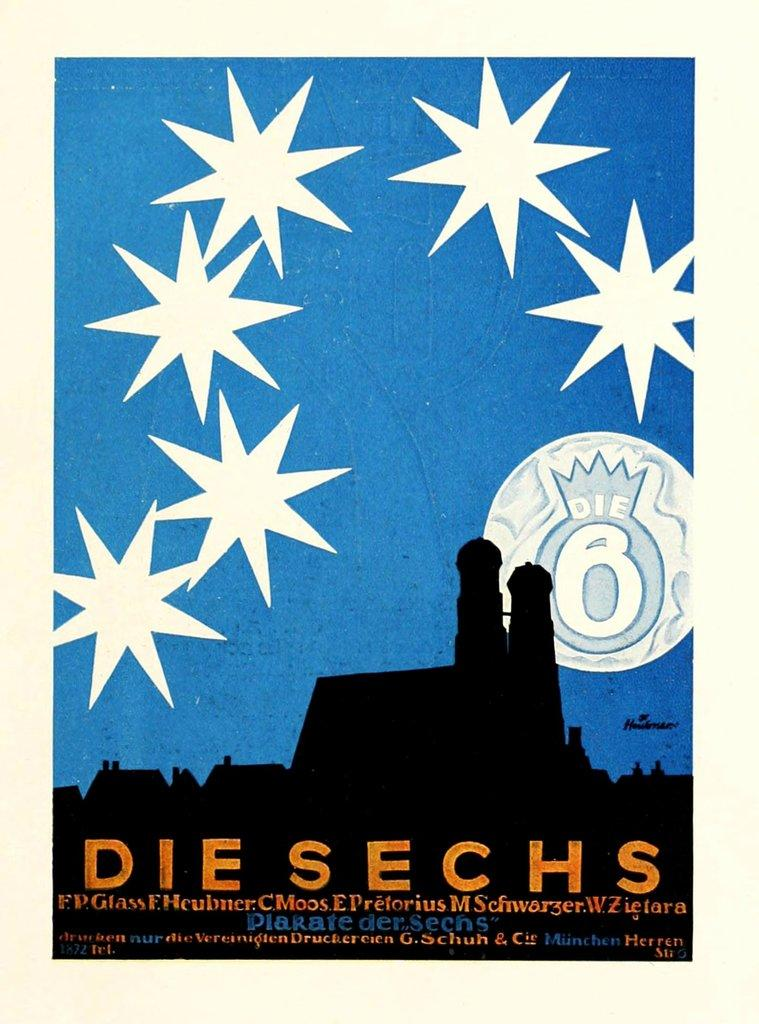<image>
Share a concise interpretation of the image provided. A picture with stars in the sky is titled Die Sechs. 